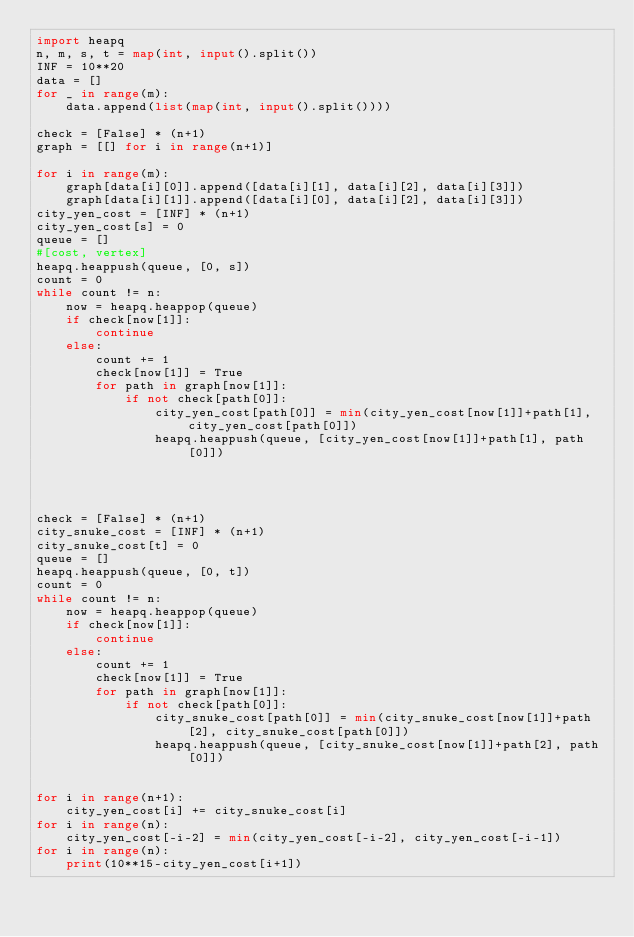<code> <loc_0><loc_0><loc_500><loc_500><_Python_>import heapq
n, m, s, t = map(int, input().split())
INF = 10**20
data = []
for _ in range(m):
    data.append(list(map(int, input().split())))

check = [False] * (n+1)
graph = [[] for i in range(n+1)]

for i in range(m):
    graph[data[i][0]].append([data[i][1], data[i][2], data[i][3]])
    graph[data[i][1]].append([data[i][0], data[i][2], data[i][3]])
city_yen_cost = [INF] * (n+1)
city_yen_cost[s] = 0
queue = []
#[cost, vertex]
heapq.heappush(queue, [0, s])
count = 0
while count != n:
    now = heapq.heappop(queue)
    if check[now[1]]:
        continue
    else:
        count += 1
        check[now[1]] = True
        for path in graph[now[1]]:
            if not check[path[0]]:
                city_yen_cost[path[0]] = min(city_yen_cost[now[1]]+path[1], city_yen_cost[path[0]])
                heapq.heappush(queue, [city_yen_cost[now[1]]+path[1], path[0]])




check = [False] * (n+1)
city_snuke_cost = [INF] * (n+1)
city_snuke_cost[t] = 0
queue = []
heapq.heappush(queue, [0, t])
count = 0
while count != n:
    now = heapq.heappop(queue)
    if check[now[1]]:
        continue
    else:
        count += 1
        check[now[1]] = True
        for path in graph[now[1]]:
            if not check[path[0]]:
                city_snuke_cost[path[0]] = min(city_snuke_cost[now[1]]+path[2], city_snuke_cost[path[0]])
                heapq.heappush(queue, [city_snuke_cost[now[1]]+path[2], path[0]])


for i in range(n+1):
    city_yen_cost[i] += city_snuke_cost[i]
for i in range(n):
    city_yen_cost[-i-2] = min(city_yen_cost[-i-2], city_yen_cost[-i-1])
for i in range(n):
    print(10**15-city_yen_cost[i+1])
</code> 